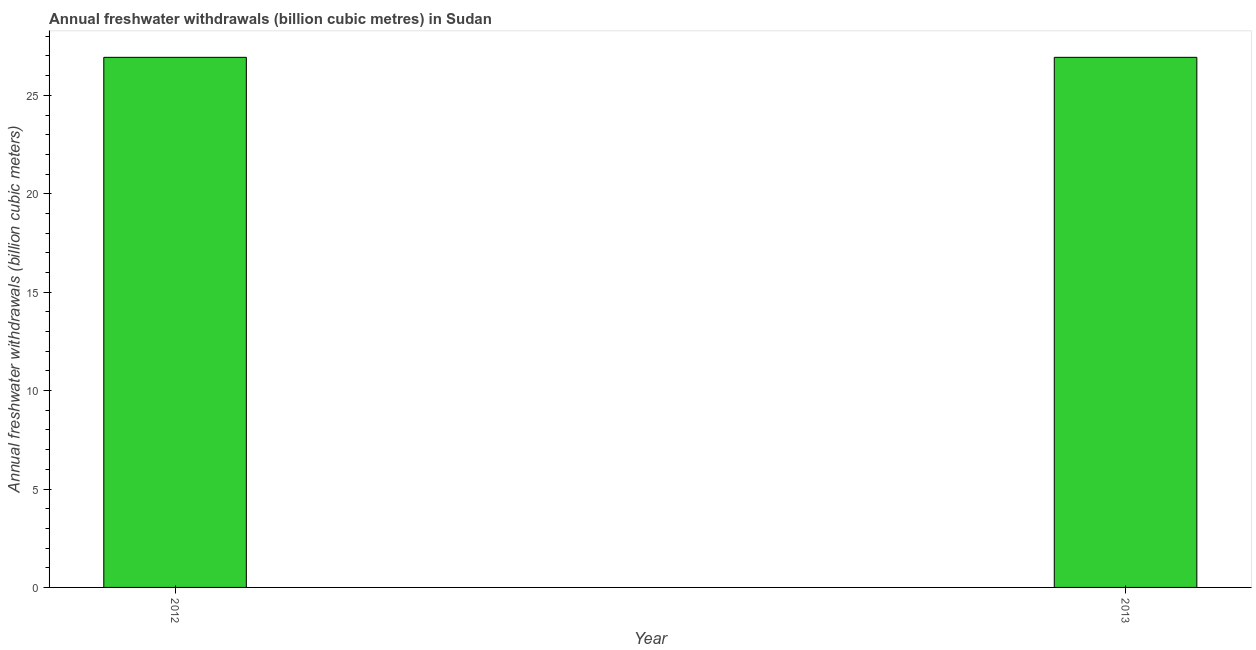Does the graph contain any zero values?
Your answer should be very brief. No. Does the graph contain grids?
Your answer should be compact. No. What is the title of the graph?
Your answer should be compact. Annual freshwater withdrawals (billion cubic metres) in Sudan. What is the label or title of the Y-axis?
Your answer should be very brief. Annual freshwater withdrawals (billion cubic meters). What is the annual freshwater withdrawals in 2012?
Provide a short and direct response. 26.93. Across all years, what is the maximum annual freshwater withdrawals?
Offer a terse response. 26.93. Across all years, what is the minimum annual freshwater withdrawals?
Your answer should be very brief. 26.93. In which year was the annual freshwater withdrawals minimum?
Your answer should be compact. 2012. What is the sum of the annual freshwater withdrawals?
Your answer should be very brief. 53.86. What is the average annual freshwater withdrawals per year?
Offer a very short reply. 26.93. What is the median annual freshwater withdrawals?
Ensure brevity in your answer.  26.93. Do a majority of the years between 2013 and 2012 (inclusive) have annual freshwater withdrawals greater than 25 billion cubic meters?
Give a very brief answer. No. What is the ratio of the annual freshwater withdrawals in 2012 to that in 2013?
Ensure brevity in your answer.  1. In how many years, is the annual freshwater withdrawals greater than the average annual freshwater withdrawals taken over all years?
Offer a very short reply. 0. Are all the bars in the graph horizontal?
Your answer should be very brief. No. What is the Annual freshwater withdrawals (billion cubic meters) of 2012?
Ensure brevity in your answer.  26.93. What is the Annual freshwater withdrawals (billion cubic meters) of 2013?
Make the answer very short. 26.93. What is the difference between the Annual freshwater withdrawals (billion cubic meters) in 2012 and 2013?
Your answer should be compact. 0. What is the ratio of the Annual freshwater withdrawals (billion cubic meters) in 2012 to that in 2013?
Ensure brevity in your answer.  1. 